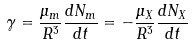Convert formula to latex. <formula><loc_0><loc_0><loc_500><loc_500>\gamma = \frac { \mu _ { m } } { R ^ { 3 } } \frac { d N _ { m } } { d t } = - \frac { \mu _ { X } } { R ^ { 3 } } \frac { d N _ { X } } { d t }</formula> 